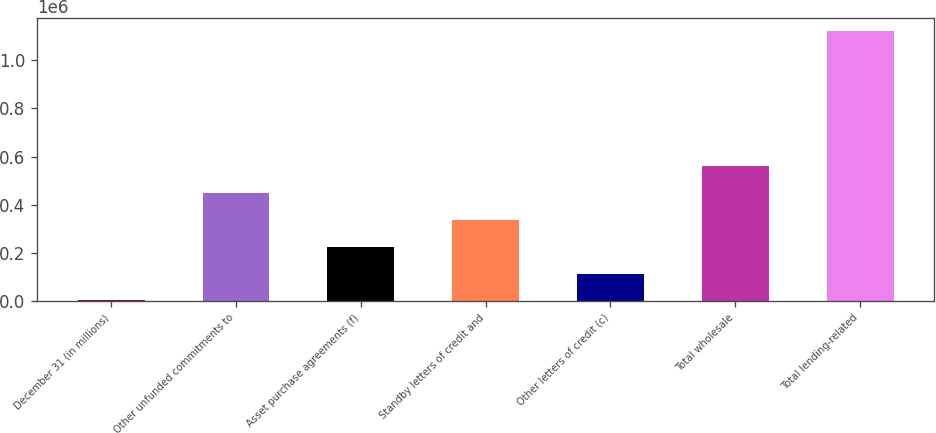Convert chart to OTSL. <chart><loc_0><loc_0><loc_500><loc_500><bar_chart><fcel>December 31 (in millions)<fcel>Other unfunded commitments to<fcel>Asset purchase agreements (f)<fcel>Standby letters of credit and<fcel>Other letters of credit (c)<fcel>Total wholesale<fcel>Total lending-related<nl><fcel>2008<fcel>449756<fcel>225882<fcel>337819<fcel>113945<fcel>561693<fcel>1.12138e+06<nl></chart> 